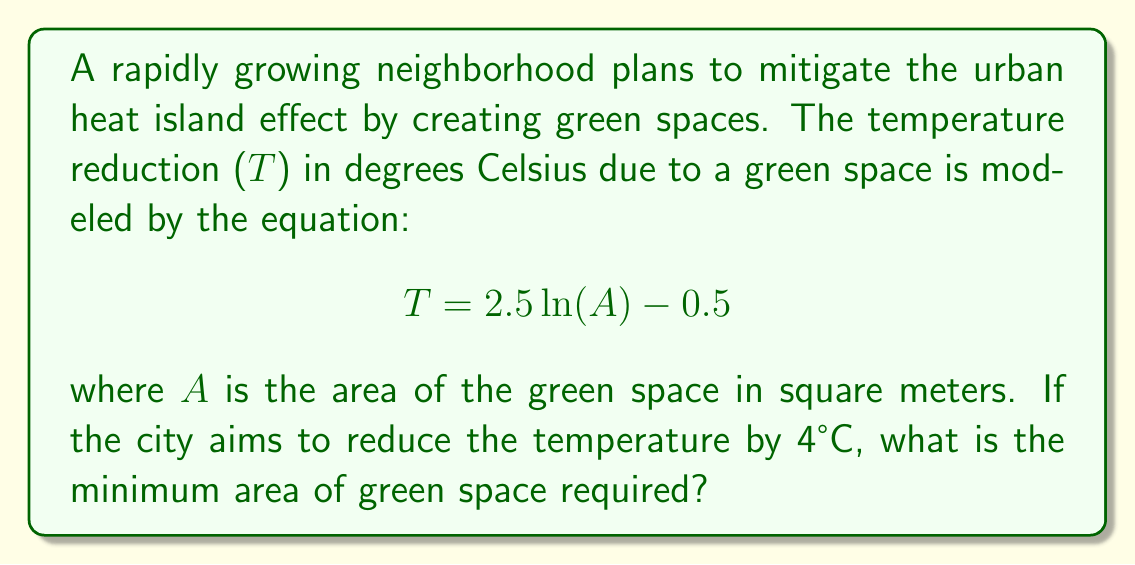Solve this math problem. To solve this problem, we'll follow these steps:

1) We're given the equation: $$T = 2.5 \ln(A) - 0.5$$

2) We want to find A when T = 4°C. Let's substitute this:

   $$4 = 2.5 \ln(A) - 0.5$$

3) Add 0.5 to both sides:

   $$4.5 = 2.5 \ln(A)$$

4) Divide both sides by 2.5:

   $$1.8 = \ln(A)$$

5) To solve for A, we need to apply the exponential function (e^x) to both sides:

   $$e^{1.8} = e^{\ln(A)}$$

6) The left side becomes a number, and e^ln(A) simplifies to just A:

   $$e^{1.8} = A$$

7) Calculate e^1.8:

   $$A \approx 6.04965$$

8) Since we're dealing with area, we need to round up to the nearest whole number:

   $$A = 7 \text{ square meters}$$

Therefore, the minimum area of green space required is 7 square meters.
Answer: 7 square meters 